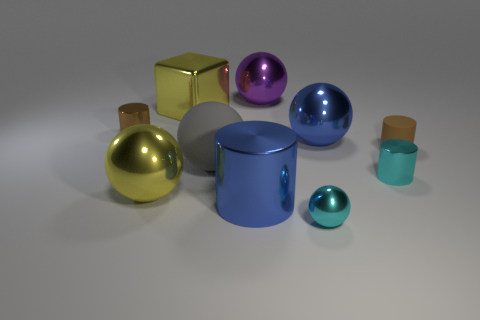Subtract 2 spheres. How many spheres are left? 3 Subtract all cyan balls. How many balls are left? 4 Subtract all gray spheres. How many spheres are left? 4 Subtract all brown balls. Subtract all blue cubes. How many balls are left? 5 Subtract all cubes. How many objects are left? 9 Add 2 blocks. How many blocks exist? 3 Subtract 0 cyan blocks. How many objects are left? 10 Subtract all small yellow metallic balls. Subtract all large blue things. How many objects are left? 8 Add 9 gray balls. How many gray balls are left? 10 